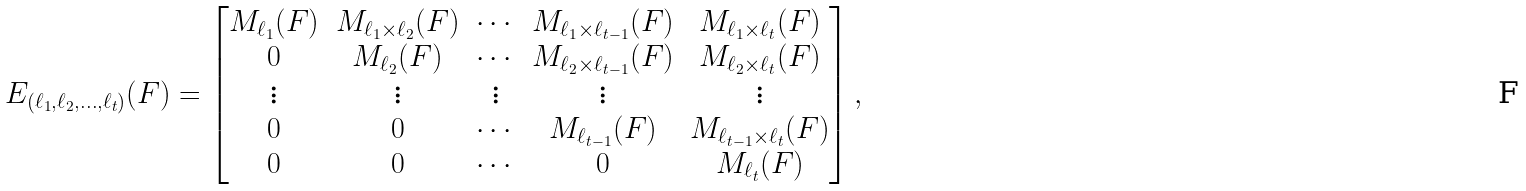Convert formula to latex. <formula><loc_0><loc_0><loc_500><loc_500>E _ { ( \ell _ { 1 } , \ell _ { 2 } , \dots , \ell _ { t } ) } ( F ) = \begin{bmatrix} M _ { \ell _ { 1 } } ( F ) & M _ { \ell _ { 1 } \times \ell _ { 2 } } ( F ) & \cdots & M _ { \ell _ { 1 } \times \ell _ { t - 1 } } ( F ) & M _ { \ell _ { 1 } \times \ell _ { t } } ( F ) \\ 0 & M _ { \ell _ { 2 } } ( F ) & \cdots & M _ { \ell _ { 2 } \times \ell _ { t - 1 } } ( F ) & M _ { \ell _ { 2 } \times \ell _ { t } } ( F ) \\ \vdots & \vdots & \vdots & \vdots & \vdots \\ 0 & 0 & \cdots & M _ { \ell _ { t - 1 } } ( F ) & M _ { \ell _ { t - 1 } \times \ell _ { t } } ( F ) \\ 0 & 0 & \cdots & 0 & M _ { \ell _ { t } } ( F ) \\ \end{bmatrix} ,</formula> 